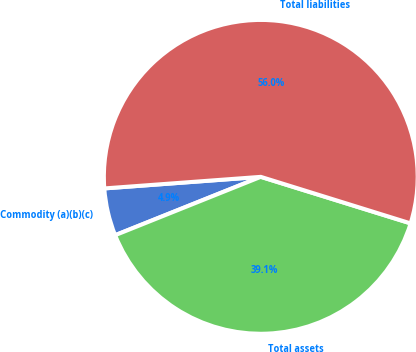Convert chart. <chart><loc_0><loc_0><loc_500><loc_500><pie_chart><fcel>Commodity (a)(b)(c)<fcel>Total assets<fcel>Total liabilities<nl><fcel>4.89%<fcel>39.14%<fcel>55.97%<nl></chart> 